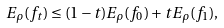Convert formula to latex. <formula><loc_0><loc_0><loc_500><loc_500>E _ { \rho } ( f _ { t } ) \leq ( 1 - t ) E _ { \rho } ( f _ { 0 } ) + t E _ { \rho } ( f _ { 1 } ) ,</formula> 